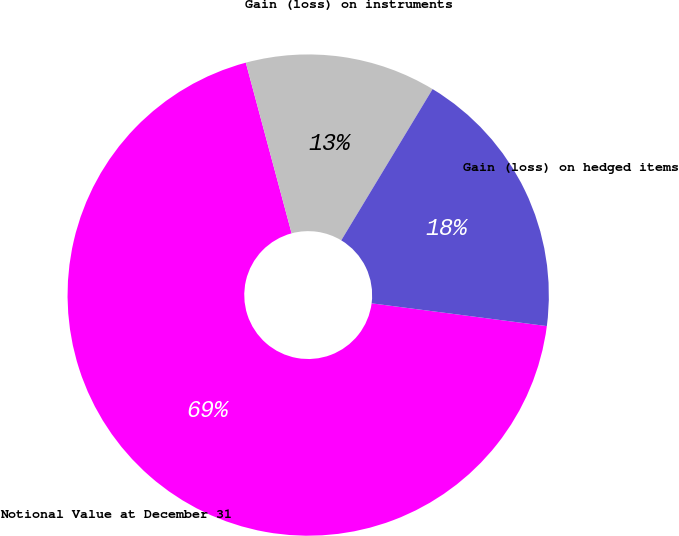Convert chart to OTSL. <chart><loc_0><loc_0><loc_500><loc_500><pie_chart><fcel>Notional Value at December 31<fcel>Gain (loss) on instruments<fcel>Gain (loss) on hedged items<nl><fcel>68.77%<fcel>12.82%<fcel>18.41%<nl></chart> 